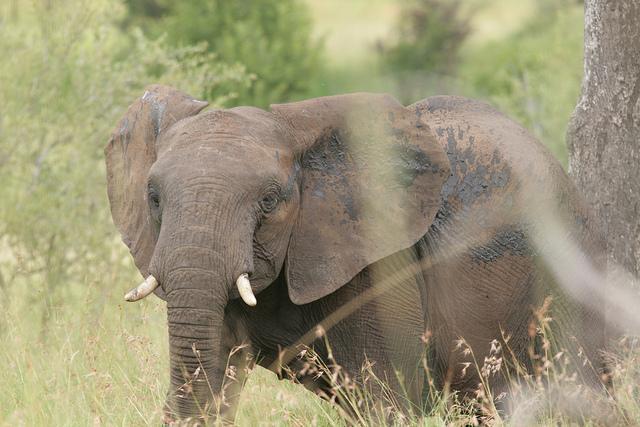How many tusks are there?
Give a very brief answer. 2. How many elephants are in the picture?
Give a very brief answer. 1. How many women are in the picture?
Give a very brief answer. 0. 